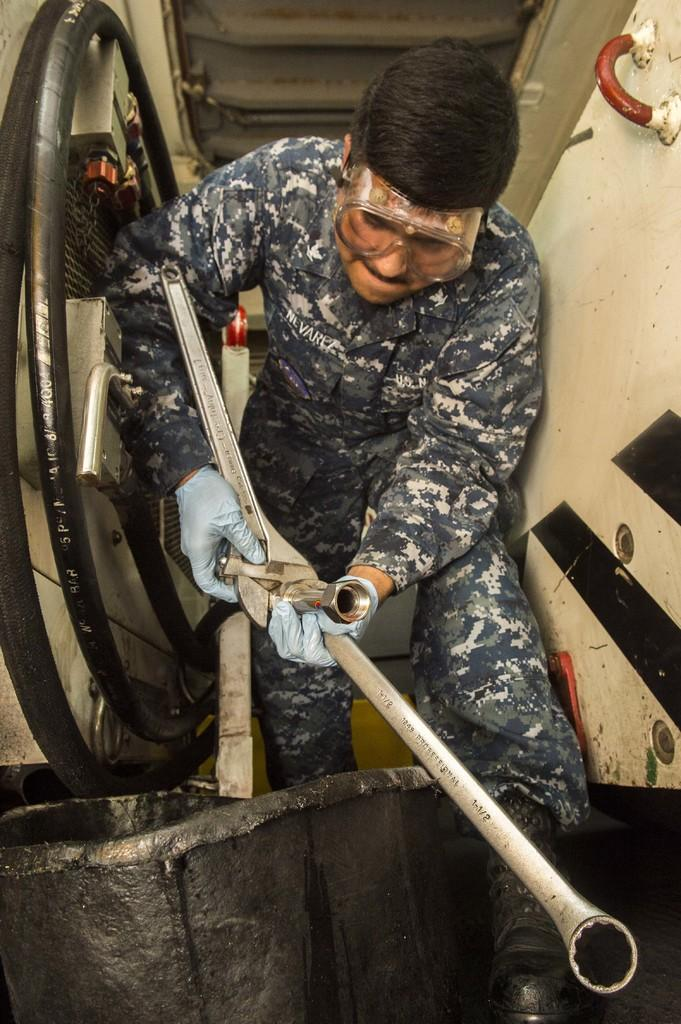What is the main subject of the image? There is a person in the center of the image. What is the person doing in the image? The person is holding an object in their hand. What type of sweater is the grandmother wearing in the image? There is no mention of a sweater or a grandmother in the provided facts, so we cannot answer this question. 